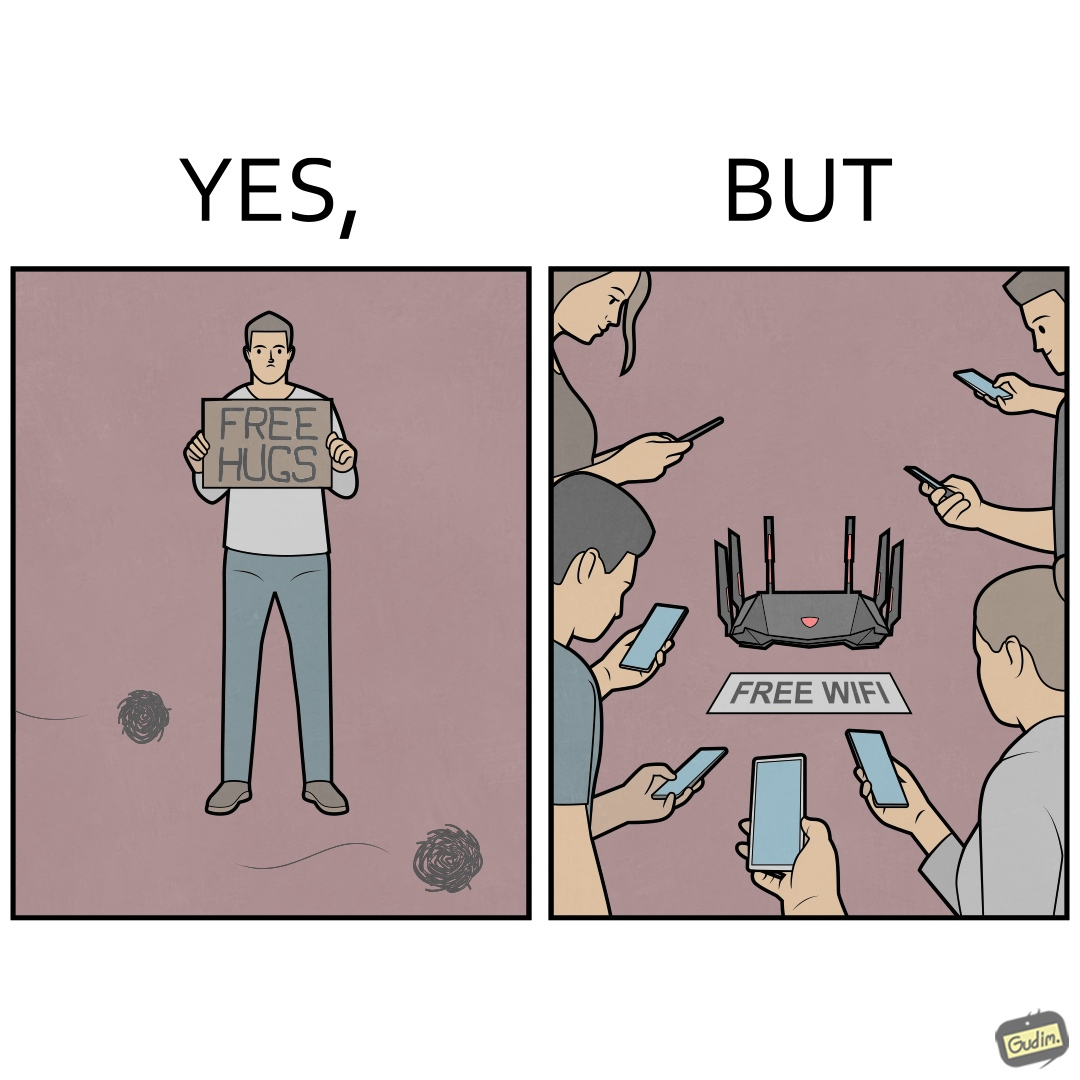What do you see in each half of this image? In the left part of the image: a person standing alone holding a sign "Free Hugs". The tumbleweeds blowing in the wind further stress on the loneliness. In the right part of the image: A Wi-fi Router with the label "Free Wifi" in front of it, surrounded by people trying to connect to it on their mobile devices. 